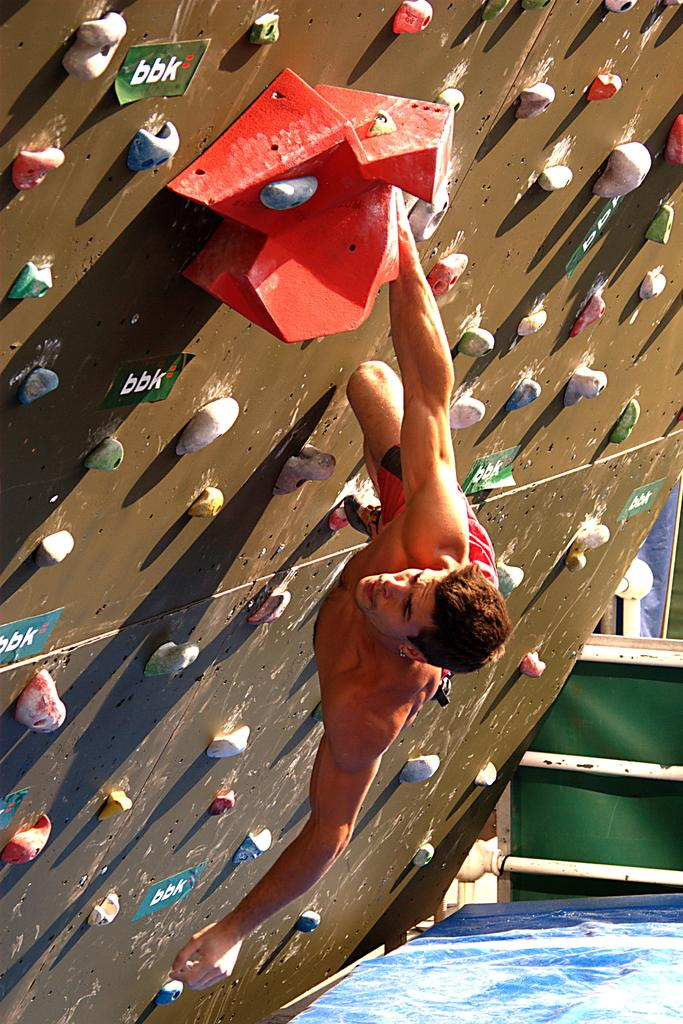Who is in the image? There is a man in the image. What is the man doing in the image? The man is climbing a wall. What type of wall is the man climbing? The wall is for bouldering. What can be seen attached to the wall? There are objects attached to the wall. What is visible at the bottom of the image? There is water visible at the bottom of the image. What are the metal rods at the bottom of the image used for? The metal rods at the bottom of the image are likely used for support or safety. What type of pies can be seen floating in the water at the bottom of the image? There are no pies visible in the water at the bottom of the image. 